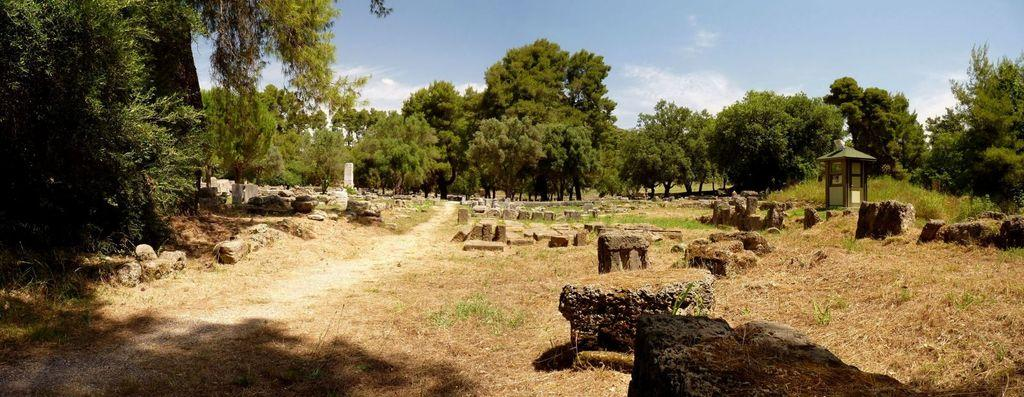What type of vegetation can be seen in the image? There are trees, plants, and grass visible in the image. What type of ground surface is present in the image? There are stones and land visible in the image. What type of structure is in the image? There is a house in the image. What part of the natural environment is visible in the image? The sky is visible in the image, along with clouds. What type of sign can be seen pointing towards the operation in the image? There is no sign or operation present in the image. 